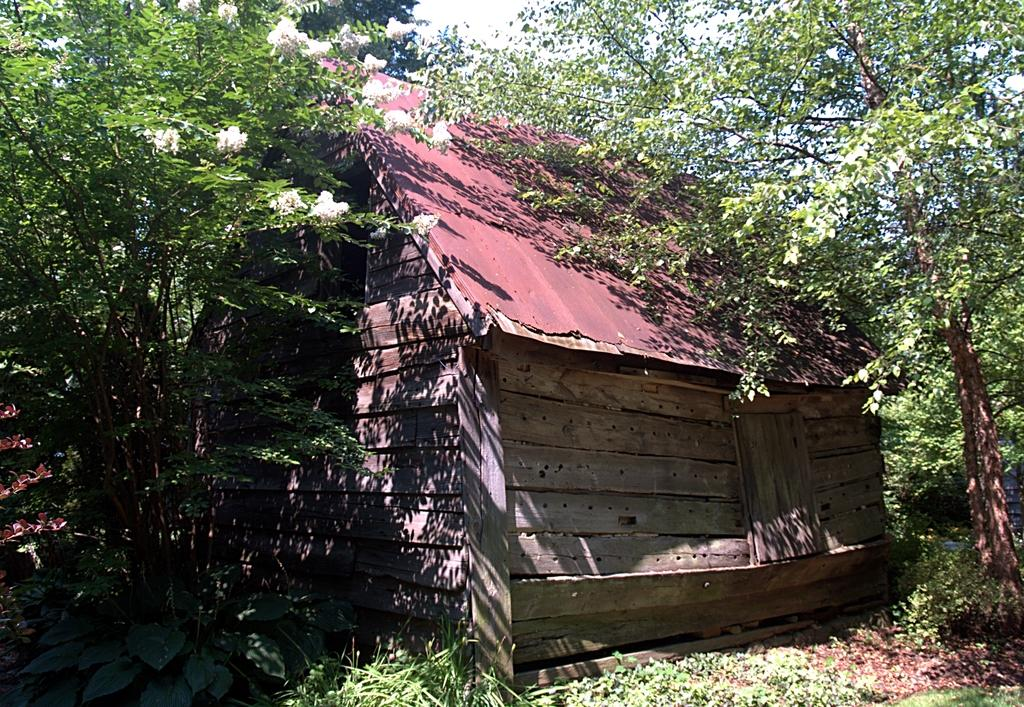What type of vegetation can be seen in the image? There are trees in the image. What type of structure is visible in the image? There is a house in the image. What is visible at the top of the image? The sky is visible at the top of the image. How many pears are hanging from the trees in the image? There are no pears visible in the image; only trees are present. What type of feet can be seen on the house in the image? There are no feet visible in the image; the house is a structure and does not have feet. 